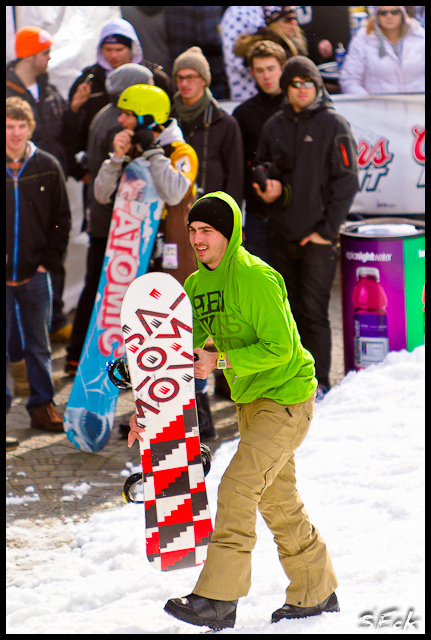Read and extract the text from this image. ATOMIC us IT SEck 